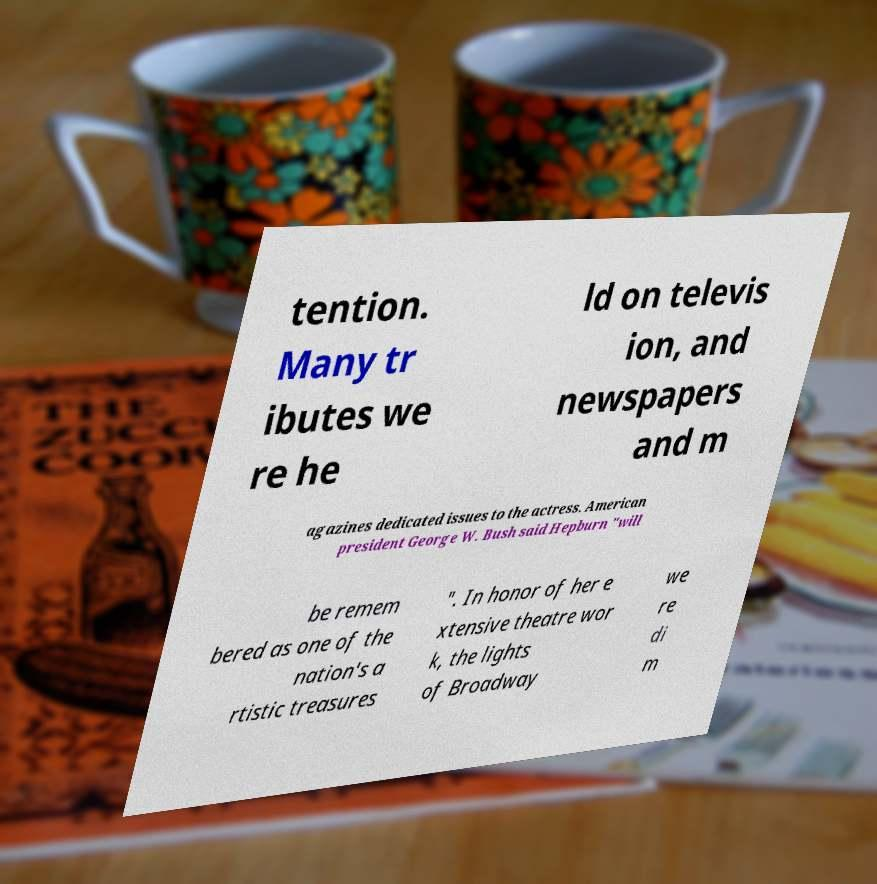What messages or text are displayed in this image? I need them in a readable, typed format. tention. Many tr ibutes we re he ld on televis ion, and newspapers and m agazines dedicated issues to the actress. American president George W. Bush said Hepburn "will be remem bered as one of the nation's a rtistic treasures ". In honor of her e xtensive theatre wor k, the lights of Broadway we re di m 